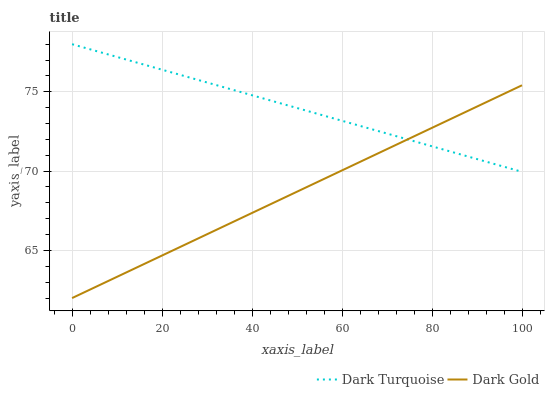Does Dark Gold have the minimum area under the curve?
Answer yes or no. Yes. Does Dark Turquoise have the maximum area under the curve?
Answer yes or no. Yes. Does Dark Gold have the maximum area under the curve?
Answer yes or no. No. Is Dark Turquoise the smoothest?
Answer yes or no. Yes. Is Dark Gold the roughest?
Answer yes or no. Yes. Is Dark Gold the smoothest?
Answer yes or no. No. Does Dark Gold have the lowest value?
Answer yes or no. Yes. Does Dark Turquoise have the highest value?
Answer yes or no. Yes. Does Dark Gold have the highest value?
Answer yes or no. No. Does Dark Gold intersect Dark Turquoise?
Answer yes or no. Yes. Is Dark Gold less than Dark Turquoise?
Answer yes or no. No. Is Dark Gold greater than Dark Turquoise?
Answer yes or no. No. 